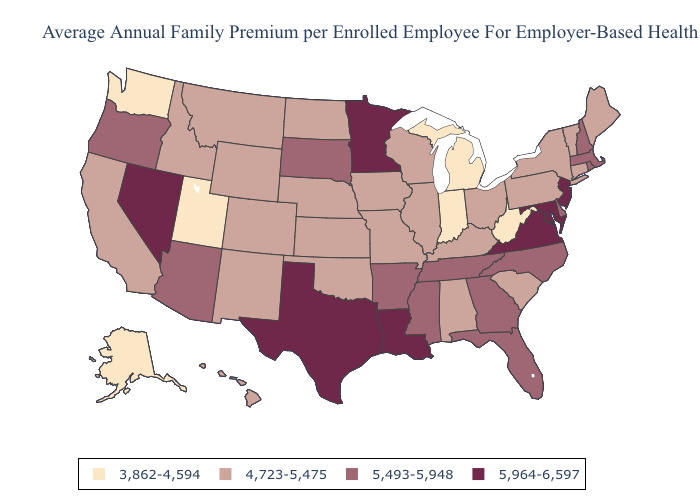Does the first symbol in the legend represent the smallest category?
Answer briefly. Yes. Which states hav the highest value in the Northeast?
Give a very brief answer. New Jersey. Name the states that have a value in the range 3,862-4,594?
Quick response, please. Alaska, Indiana, Michigan, Utah, Washington, West Virginia. Does North Carolina have the lowest value in the USA?
Be succinct. No. Name the states that have a value in the range 5,493-5,948?
Concise answer only. Arizona, Arkansas, Delaware, Florida, Georgia, Massachusetts, Mississippi, New Hampshire, North Carolina, Oregon, Rhode Island, South Dakota, Tennessee. What is the value of Louisiana?
Give a very brief answer. 5,964-6,597. Does North Dakota have the highest value in the USA?
Be succinct. No. Name the states that have a value in the range 4,723-5,475?
Give a very brief answer. Alabama, California, Colorado, Connecticut, Hawaii, Idaho, Illinois, Iowa, Kansas, Kentucky, Maine, Missouri, Montana, Nebraska, New Mexico, New York, North Dakota, Ohio, Oklahoma, Pennsylvania, South Carolina, Vermont, Wisconsin, Wyoming. How many symbols are there in the legend?
Write a very short answer. 4. Name the states that have a value in the range 5,964-6,597?
Short answer required. Louisiana, Maryland, Minnesota, Nevada, New Jersey, Texas, Virginia. What is the value of Florida?
Short answer required. 5,493-5,948. Name the states that have a value in the range 5,964-6,597?
Keep it brief. Louisiana, Maryland, Minnesota, Nevada, New Jersey, Texas, Virginia. Does Michigan have a lower value than Utah?
Be succinct. No. What is the highest value in the West ?
Short answer required. 5,964-6,597. 